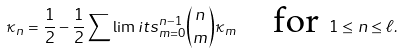Convert formula to latex. <formula><loc_0><loc_0><loc_500><loc_500>\kappa _ { n } = \frac { 1 } { 2 } - \frac { 1 } { 2 } \sum \lim i t s _ { m = 0 } ^ { n - 1 } \binom { n } { m } \kappa _ { m } \quad \text {for } 1 \leq n \leq \ell .</formula> 